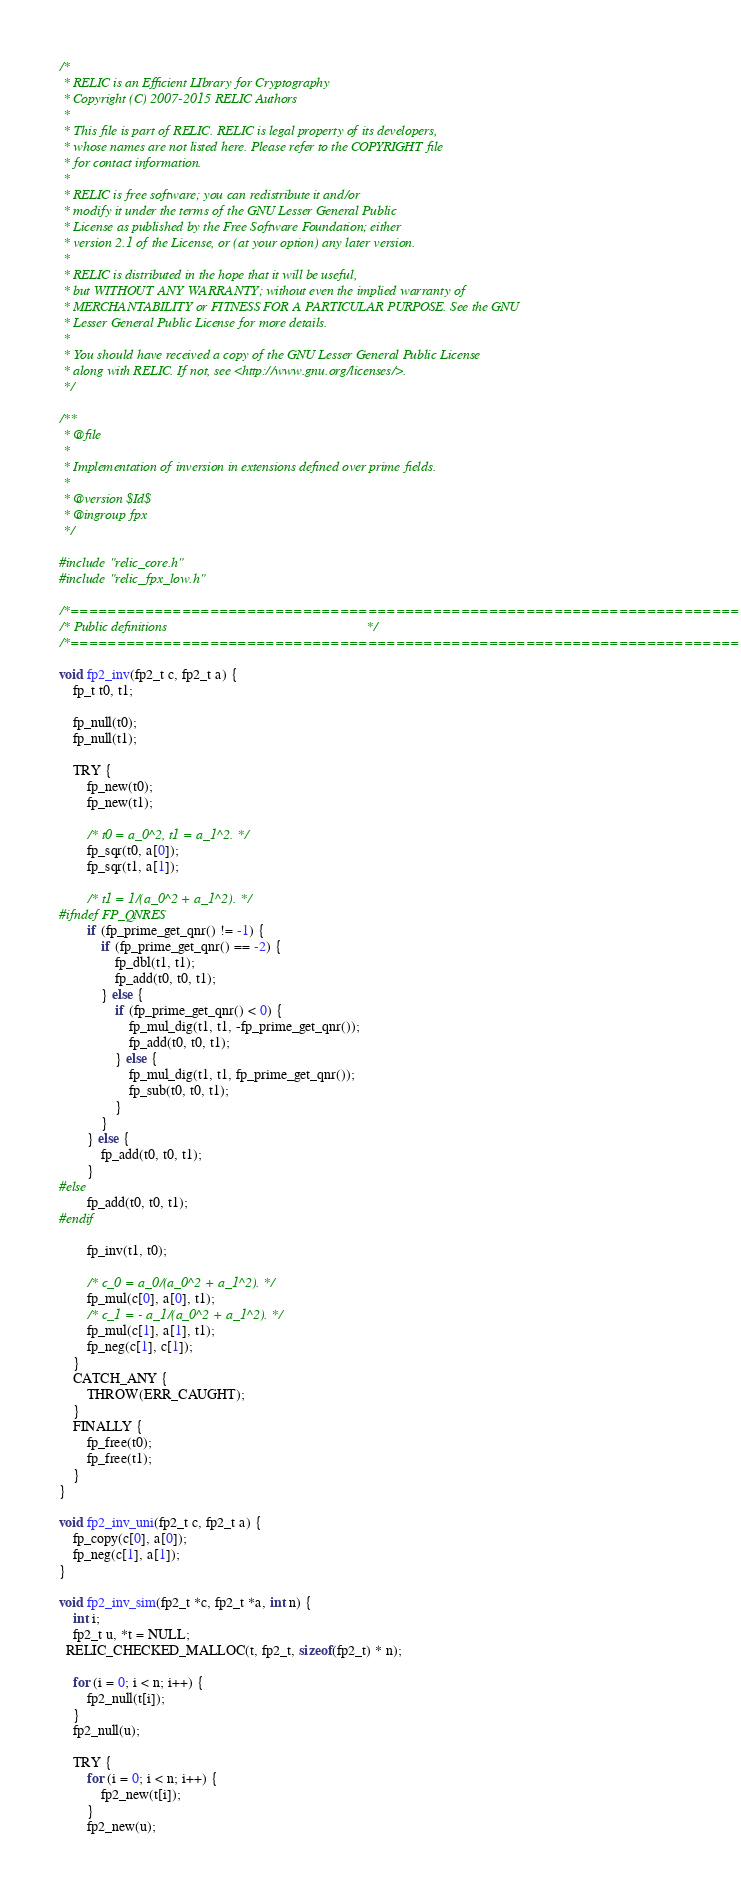<code> <loc_0><loc_0><loc_500><loc_500><_C_>/*
 * RELIC is an Efficient LIbrary for Cryptography
 * Copyright (C) 2007-2015 RELIC Authors
 *
 * This file is part of RELIC. RELIC is legal property of its developers,
 * whose names are not listed here. Please refer to the COPYRIGHT file
 * for contact information.
 *
 * RELIC is free software; you can redistribute it and/or
 * modify it under the terms of the GNU Lesser General Public
 * License as published by the Free Software Foundation; either
 * version 2.1 of the License, or (at your option) any later version.
 *
 * RELIC is distributed in the hope that it will be useful,
 * but WITHOUT ANY WARRANTY; without even the implied warranty of
 * MERCHANTABILITY or FITNESS FOR A PARTICULAR PURPOSE. See the GNU
 * Lesser General Public License for more details.
 *
 * You should have received a copy of the GNU Lesser General Public License
 * along with RELIC. If not, see <http://www.gnu.org/licenses/>.
 */

/**
 * @file
 *
 * Implementation of inversion in extensions defined over prime fields.
 *
 * @version $Id$
 * @ingroup fpx
 */

#include "relic_core.h"
#include "relic_fpx_low.h"

/*============================================================================*/
/* Public definitions                                                         */
/*============================================================================*/

void fp2_inv(fp2_t c, fp2_t a) {
	fp_t t0, t1;

	fp_null(t0);
	fp_null(t1);

	TRY {
		fp_new(t0);
		fp_new(t1);

		/* t0 = a_0^2, t1 = a_1^2. */
		fp_sqr(t0, a[0]);
		fp_sqr(t1, a[1]);

		/* t1 = 1/(a_0^2 + a_1^2). */
#ifndef FP_QNRES
		if (fp_prime_get_qnr() != -1) {
			if (fp_prime_get_qnr() == -2) {
				fp_dbl(t1, t1);
				fp_add(t0, t0, t1);
			} else {
				if (fp_prime_get_qnr() < 0) {
					fp_mul_dig(t1, t1, -fp_prime_get_qnr());
					fp_add(t0, t0, t1);
				} else {
					fp_mul_dig(t1, t1, fp_prime_get_qnr());
					fp_sub(t0, t0, t1);
				}
			}
		} else {
			fp_add(t0, t0, t1);
		}
#else
		fp_add(t0, t0, t1);
#endif

		fp_inv(t1, t0);

		/* c_0 = a_0/(a_0^2 + a_1^2). */
		fp_mul(c[0], a[0], t1);
		/* c_1 = - a_1/(a_0^2 + a_1^2). */
		fp_mul(c[1], a[1], t1);
		fp_neg(c[1], c[1]);
	}
	CATCH_ANY {
		THROW(ERR_CAUGHT);
	}
	FINALLY {
		fp_free(t0);
		fp_free(t1);
	}
}

void fp2_inv_uni(fp2_t c, fp2_t a) {
	fp_copy(c[0], a[0]);
	fp_neg(c[1], a[1]);
}

void fp2_inv_sim(fp2_t *c, fp2_t *a, int n) {
	int i;
	fp2_t u, *t = NULL;
  RELIC_CHECKED_MALLOC(t, fp2_t, sizeof(fp2_t) * n);

	for (i = 0; i < n; i++) {
		fp2_null(t[i]);
	}
	fp2_null(u);

	TRY {
		for (i = 0; i < n; i++) {
			fp2_new(t[i]);
		}
		fp2_new(u);
</code> 